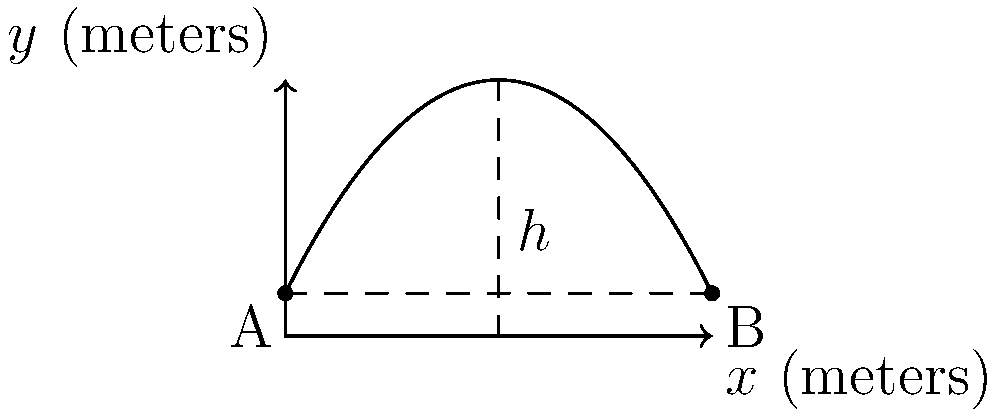As an enthusiastic skateboarder visiting Puerto Vallarta, you attempt a spectacular jump over a fountain. The parabolic trajectory of your skateboard is modeled by the function $f(x) = -0.2x^2 + 2x + 1$, where $x$ is the horizontal distance in meters and $f(x)$ is the height in meters. The fountain spans from point A (0, 1) to point B (10, 1). What is the maximum height reached by your skateboard during the jump? To find the maximum height of the parabolic trajectory, we need to follow these steps:

1) The parabola is given by $f(x) = -0.2x^2 + 2x + 1$

2) For a quadratic function $f(x) = ax^2 + bx + c$, the x-coordinate of the vertex is given by $x = -\frac{b}{2a}$

3) In this case, $a = -0.2$ and $b = 2$. So:

   $x = -\frac{2}{2(-0.2)} = -\frac{2}{-0.4} = 5$ meters

4) To find the maximum height, we substitute this x-value back into the original function:

   $f(5) = -0.2(5)^2 + 2(5) + 1$
         $= -0.2(25) + 10 + 1$
         $= -5 + 10 + 1$
         $= 6$ meters

5) Therefore, the maximum height reached by the skateboard is 6 meters.
Answer: 6 meters 